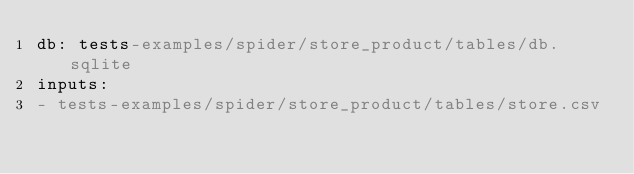<code> <loc_0><loc_0><loc_500><loc_500><_YAML_>db: tests-examples/spider/store_product/tables/db.sqlite
inputs:
- tests-examples/spider/store_product/tables/store.csv</code> 